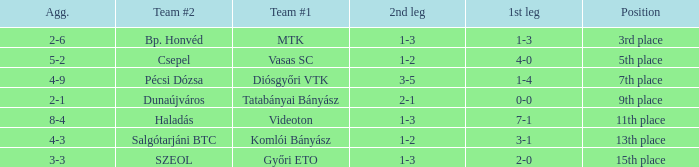What position has a 2-6 agg.? 3rd place. 